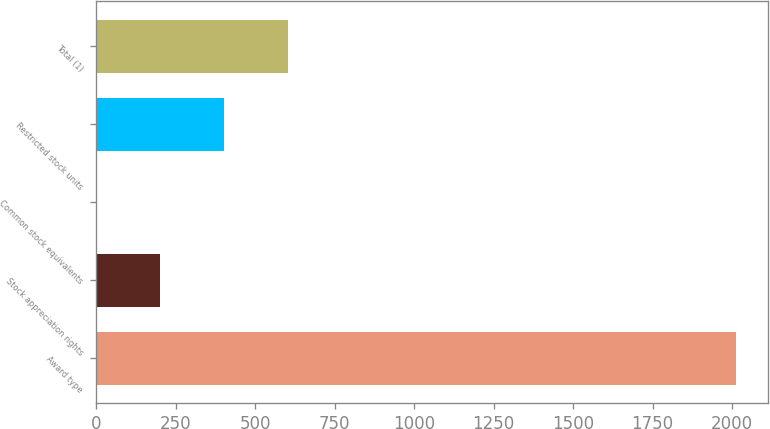Convert chart. <chart><loc_0><loc_0><loc_500><loc_500><bar_chart><fcel>Award type<fcel>Stock appreciation rights<fcel>Common stock equivalents<fcel>Restricted stock units<fcel>Total (1)<nl><fcel>2012<fcel>201.65<fcel>0.5<fcel>402.8<fcel>603.95<nl></chart> 